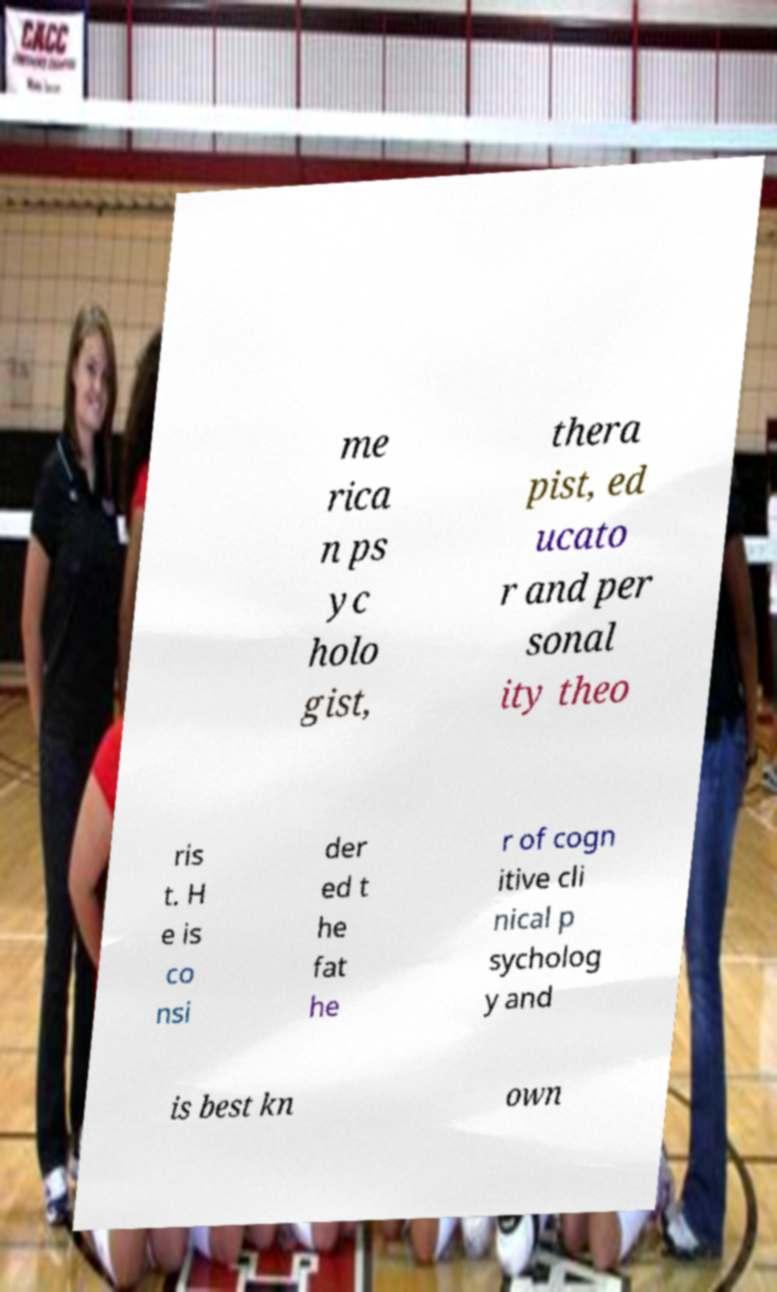What messages or text are displayed in this image? I need them in a readable, typed format. me rica n ps yc holo gist, thera pist, ed ucato r and per sonal ity theo ris t. H e is co nsi der ed t he fat he r of cogn itive cli nical p sycholog y and is best kn own 